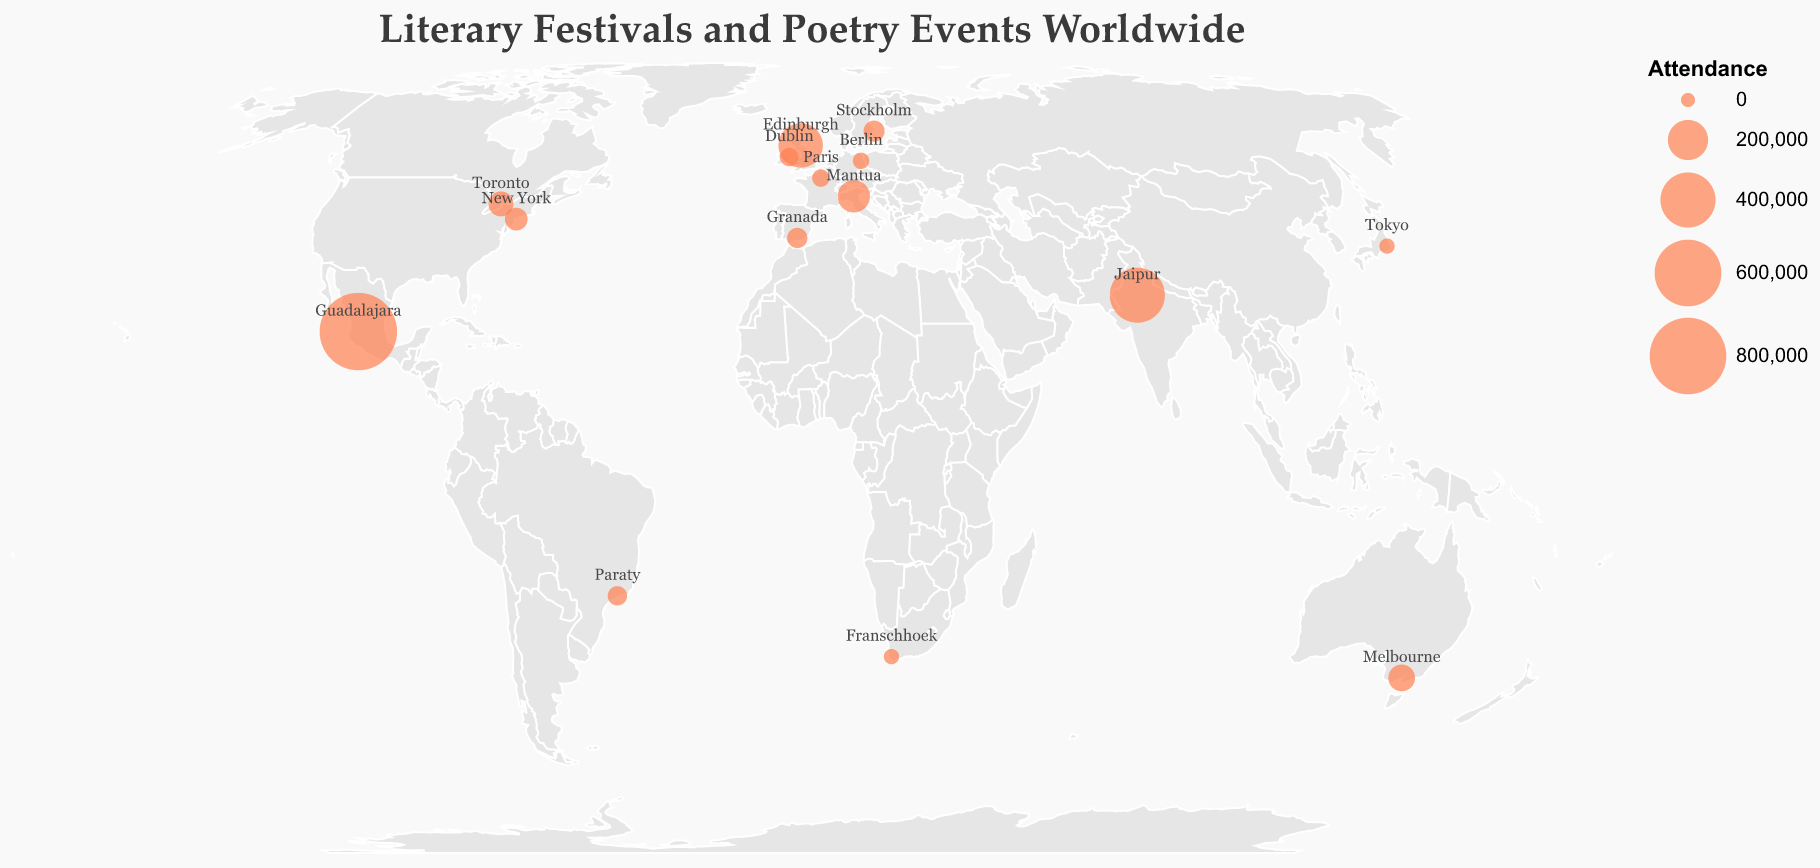What is the title of the map? The title is usually prominent and at the top of the map. By reading this, we can determine what the map represents.
Answer: Literary Festivals and Poetry Events Worldwide Which event has the highest attendance? To find this, look for the largest circle on the map. The size of each circle represents the attendance of each event.
Answer: Guadalajara International Book Fair How many annual events are there on the map? Count the number of circles (events) listed as "Annual" in their tooltip information.
Answer: 14 Which events have an attendance greater than 100,000? Look at the tooltip information for each circle and note the events where the attendance exceeds 100,000.
Answer: Edinburgh International Book Festival, Jaipur Literature Festival, Festivaletteratura, Guadalajara International Book Fair What is the frequency of the event in Paris? Find the circle for Paris and read the tooltip information to determine the frequency of its event.
Answer: Biennial What is the combined attendance of the events in Edinburgh and Dublin? Add the attendance numbers for the events in Edinburgh and Dublin found in their tooltip information.
Answer: 250,000 + 20,000 = 270,000 Which city hosts the Melbourne Writers Festival? Locate the circle for Melbourne and read the tooltip information to find the event it hosts.
Answer: Melbourne What is the difference in attendance between the Jaipur Literature Festival and Stockholm Literature? Subtract the attendance of Stockholm Literature from the attendance of Jaipur Literature Festival using the numbers provided in the tooltip.
Answer: 400,000 - 35,000 = 365,000 How does the attendance of the Festivaletteratura compare to the FLIP (Paraty International Literary Festival)? Compare the sizes of their circles or the attendance numbers from their tooltips.
Answer: Festivaletteratura has a higher attendance (120,000 vs 25,000) Are there more events in Europe or in North America on the map? Count the number of events (circles) in Europe and North America by referencing their geographical positions on the map.
Answer: Europe (6) vs North America (3) 